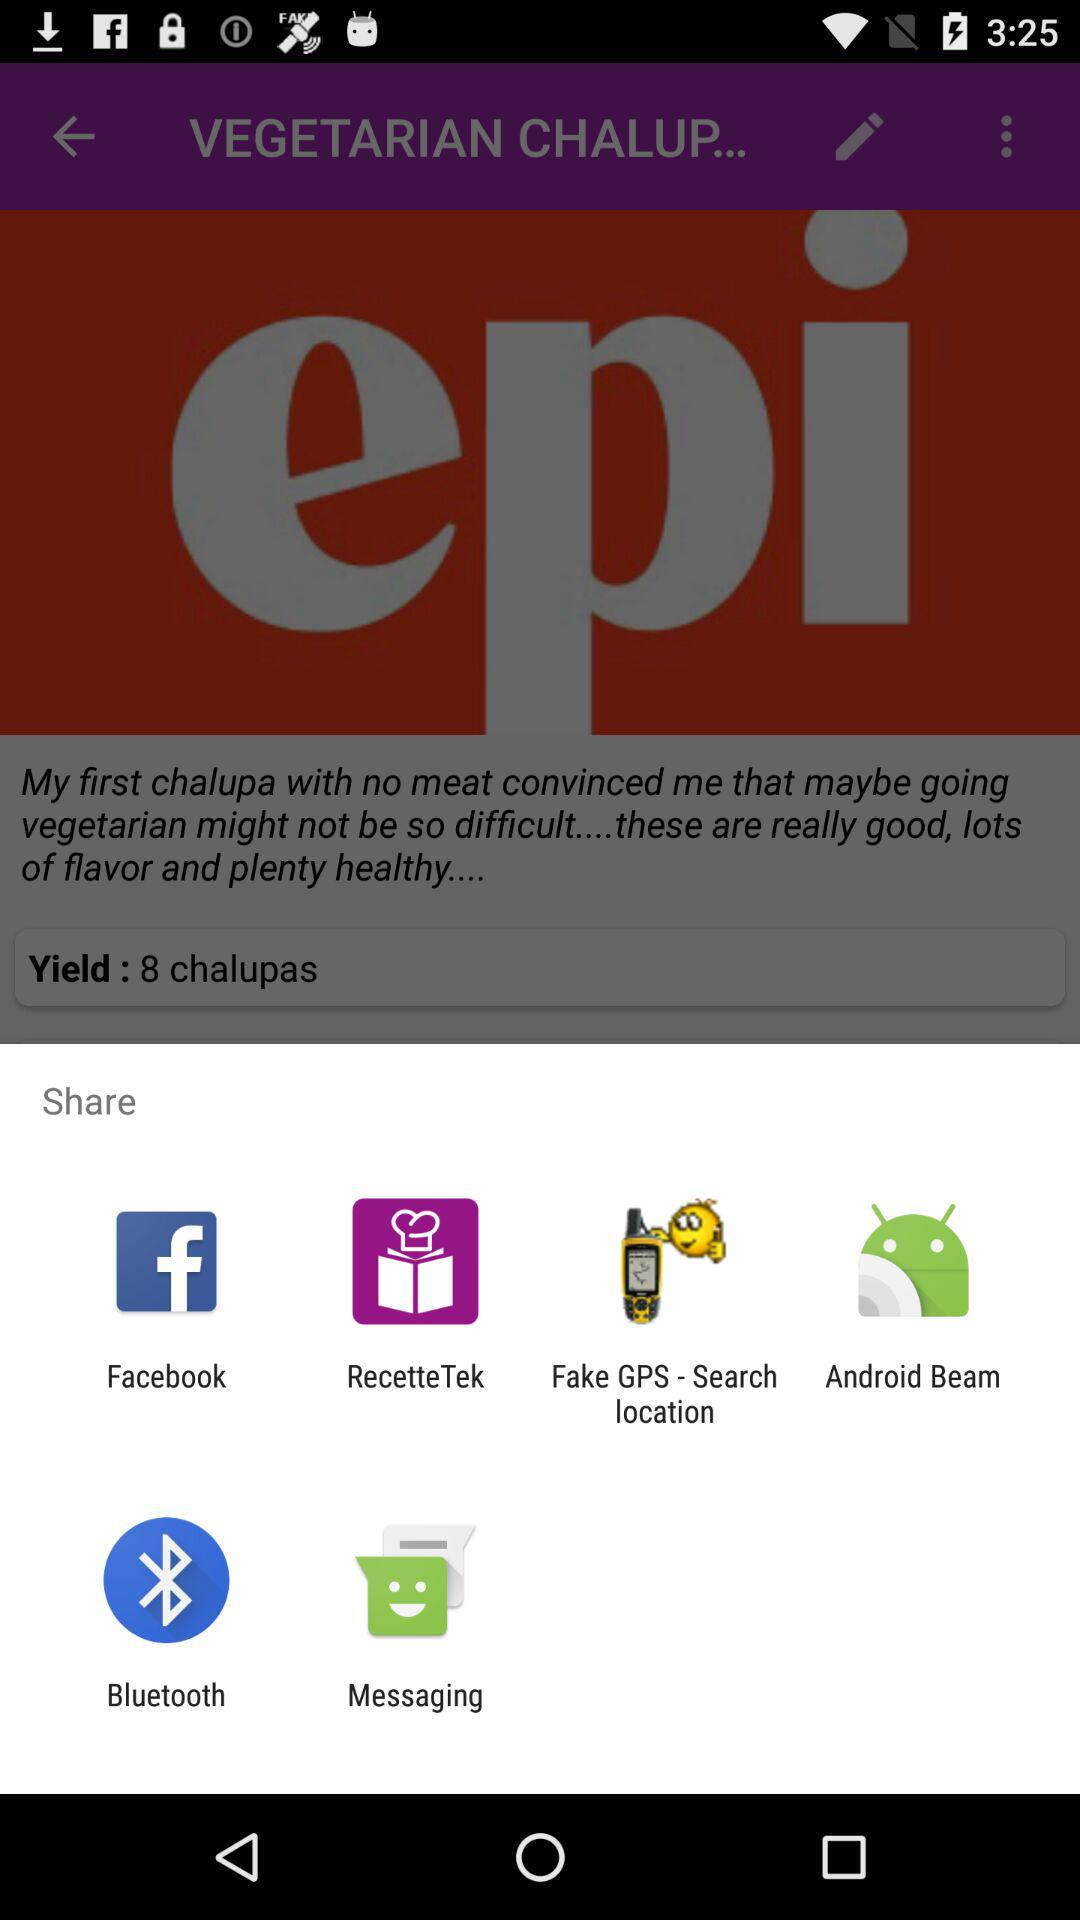What applications can we use to share? You can share with "Facebook", "Recette Tek", "Fake GPS - Search location", "Android Beam", "Bluetooth" and "Messaging". 